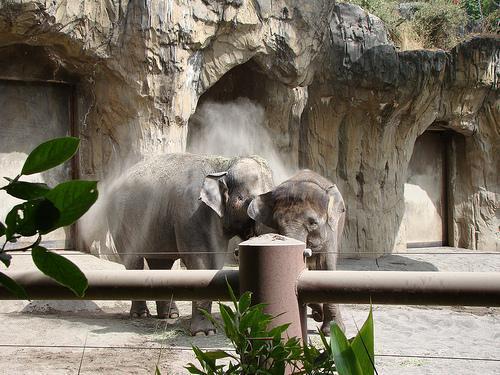How many elephants are there?
Give a very brief answer. 2. 